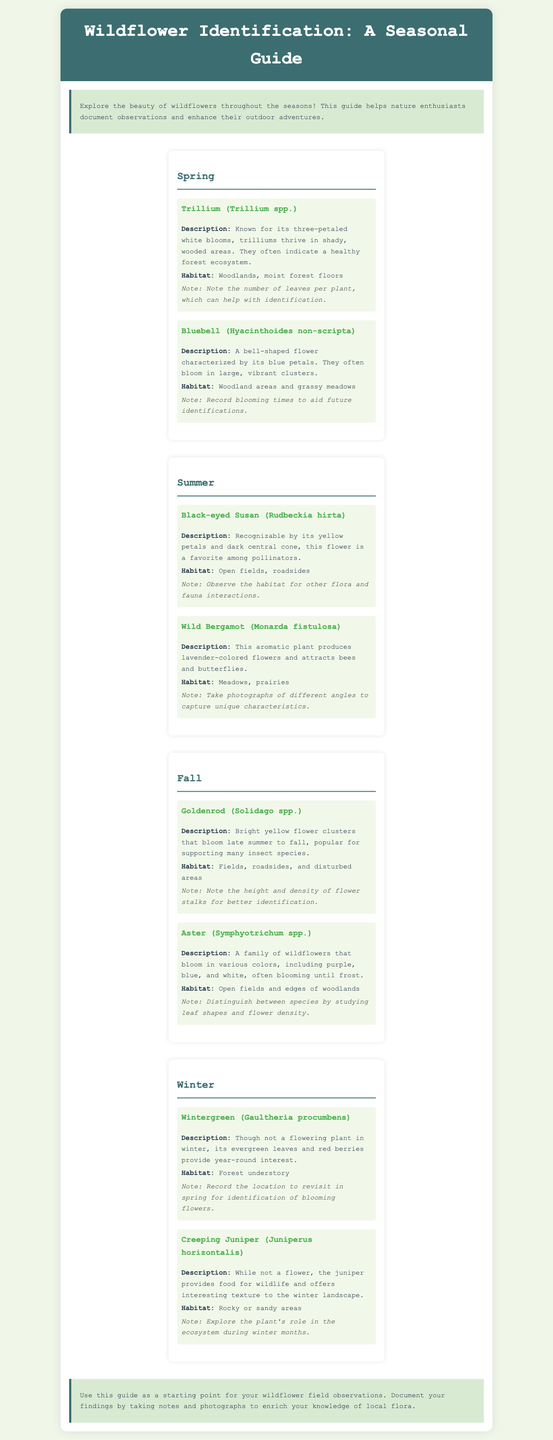what is the title of the guide? The title of the guide is stated at the top of the document under the header section.
Answer: Wildflower Identification: A Seasonal Guide how many flowers are listed for spring? The document contains a section for spring that includes two flowers.
Answer: 2 what flower is characterized by three-petaled white blooms? The description of the flower with three-petaled white blooms can be found in the spring section.
Answer: Trillium which habitat is common for Black-eyed Susan? The habitat for Black-eyed Susan is mentioned under the summer section.
Answer: Open fields, roadsides what is the color of the flower associated with Wintergreen? The description of Wintergreen does not specifically mention any flowers, focusing instead on leaves and berries.
Answer: N/A which flower blooms in late summer to fall and is popular for supporting many insect species? This information is located in the fall section of the document.
Answer: Goldenrod how is Wild Bergamot described in terms of its flower color? The flower color of Wild Bergamot is explicitly stated in its description.
Answer: Lavender-colored what is the basic function of the guide as described in the conclusion? The conclusion summarizes the guide's purpose and encourages a certain action.
Answer: Document observations 